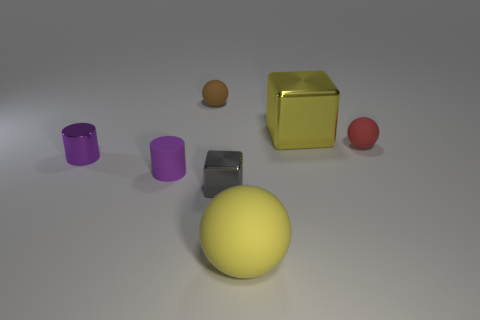Is the number of small purple things less than the number of red rubber spheres?
Give a very brief answer. No. Is the size of the red rubber sphere the same as the sphere that is to the left of the small gray metal object?
Keep it short and to the point. Yes. How many metallic objects are either blue cylinders or big yellow objects?
Make the answer very short. 1. Are there more big yellow blocks than big yellow rubber cylinders?
Ensure brevity in your answer.  Yes. There is a thing that is the same color as the rubber cylinder; what is its size?
Give a very brief answer. Small. There is a shiny object in front of the tiny metal object left of the rubber cylinder; what shape is it?
Provide a short and direct response. Cube. There is a large rubber object on the right side of the shiny block in front of the red ball; are there any tiny spheres left of it?
Offer a very short reply. Yes. What is the color of the cube that is the same size as the red ball?
Give a very brief answer. Gray. What is the shape of the small rubber thing that is both to the right of the purple rubber object and to the left of the large yellow metallic object?
Make the answer very short. Sphere. There is a rubber object left of the matte ball that is to the left of the big rubber thing; what size is it?
Give a very brief answer. Small. 